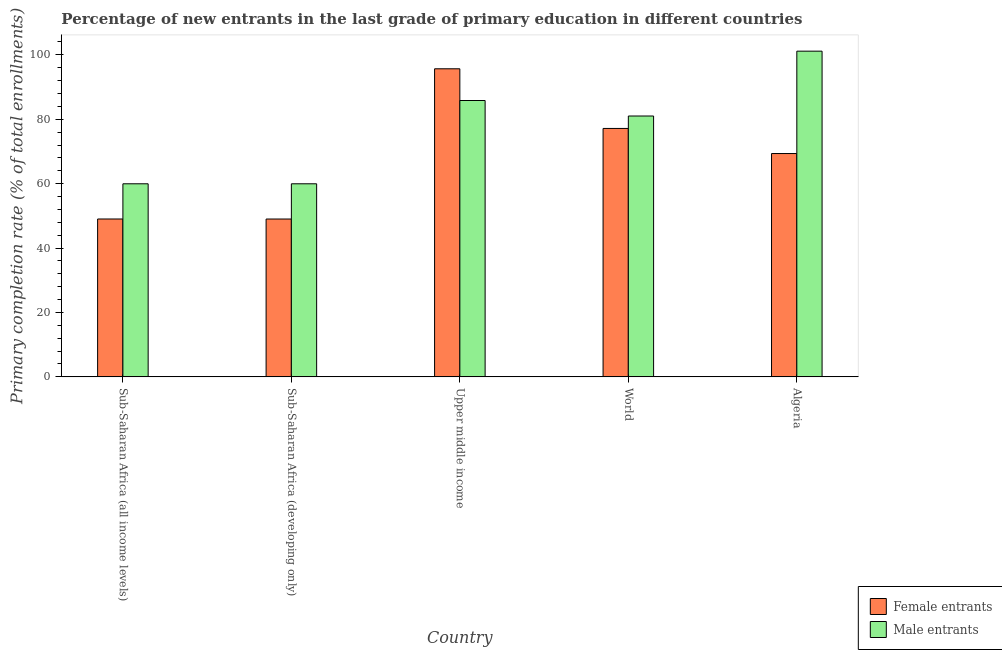How many groups of bars are there?
Your answer should be compact. 5. Are the number of bars per tick equal to the number of legend labels?
Ensure brevity in your answer.  Yes. Are the number of bars on each tick of the X-axis equal?
Provide a short and direct response. Yes. How many bars are there on the 3rd tick from the left?
Offer a terse response. 2. How many bars are there on the 3rd tick from the right?
Your response must be concise. 2. What is the label of the 2nd group of bars from the left?
Provide a short and direct response. Sub-Saharan Africa (developing only). What is the primary completion rate of male entrants in World?
Give a very brief answer. 81.01. Across all countries, what is the maximum primary completion rate of male entrants?
Offer a very short reply. 101.14. Across all countries, what is the minimum primary completion rate of male entrants?
Provide a succinct answer. 59.96. In which country was the primary completion rate of female entrants maximum?
Ensure brevity in your answer.  Upper middle income. In which country was the primary completion rate of male entrants minimum?
Offer a terse response. Sub-Saharan Africa (developing only). What is the total primary completion rate of male entrants in the graph?
Offer a very short reply. 387.89. What is the difference between the primary completion rate of male entrants in Algeria and that in Sub-Saharan Africa (developing only)?
Make the answer very short. 41.19. What is the difference between the primary completion rate of male entrants in Sub-Saharan Africa (all income levels) and the primary completion rate of female entrants in Sub-Saharan Africa (developing only)?
Your answer should be very brief. 10.94. What is the average primary completion rate of female entrants per country?
Offer a terse response. 68.04. What is the difference between the primary completion rate of male entrants and primary completion rate of female entrants in Sub-Saharan Africa (all income levels)?
Your answer should be compact. 10.94. In how many countries, is the primary completion rate of female entrants greater than 64 %?
Offer a very short reply. 3. What is the ratio of the primary completion rate of female entrants in Sub-Saharan Africa (developing only) to that in Upper middle income?
Your response must be concise. 0.51. What is the difference between the highest and the second highest primary completion rate of female entrants?
Provide a succinct answer. 18.52. What is the difference between the highest and the lowest primary completion rate of male entrants?
Your answer should be very brief. 41.19. Is the sum of the primary completion rate of male entrants in Algeria and World greater than the maximum primary completion rate of female entrants across all countries?
Offer a very short reply. Yes. What does the 1st bar from the left in Upper middle income represents?
Keep it short and to the point. Female entrants. What does the 1st bar from the right in Upper middle income represents?
Ensure brevity in your answer.  Male entrants. Are all the bars in the graph horizontal?
Ensure brevity in your answer.  No. What is the difference between two consecutive major ticks on the Y-axis?
Keep it short and to the point. 20. Does the graph contain any zero values?
Keep it short and to the point. No. Where does the legend appear in the graph?
Provide a succinct answer. Bottom right. How many legend labels are there?
Give a very brief answer. 2. What is the title of the graph?
Give a very brief answer. Percentage of new entrants in the last grade of primary education in different countries. What is the label or title of the Y-axis?
Give a very brief answer. Primary completion rate (% of total enrollments). What is the Primary completion rate (% of total enrollments) of Female entrants in Sub-Saharan Africa (all income levels)?
Give a very brief answer. 49.02. What is the Primary completion rate (% of total enrollments) in Male entrants in Sub-Saharan Africa (all income levels)?
Offer a very short reply. 59.96. What is the Primary completion rate (% of total enrollments) of Female entrants in Sub-Saharan Africa (developing only)?
Your answer should be very brief. 49.02. What is the Primary completion rate (% of total enrollments) of Male entrants in Sub-Saharan Africa (developing only)?
Your response must be concise. 59.96. What is the Primary completion rate (% of total enrollments) in Female entrants in Upper middle income?
Make the answer very short. 95.67. What is the Primary completion rate (% of total enrollments) of Male entrants in Upper middle income?
Provide a succinct answer. 85.82. What is the Primary completion rate (% of total enrollments) in Female entrants in World?
Provide a short and direct response. 77.14. What is the Primary completion rate (% of total enrollments) in Male entrants in World?
Give a very brief answer. 81.01. What is the Primary completion rate (% of total enrollments) in Female entrants in Algeria?
Your answer should be compact. 69.35. What is the Primary completion rate (% of total enrollments) in Male entrants in Algeria?
Give a very brief answer. 101.14. Across all countries, what is the maximum Primary completion rate (% of total enrollments) of Female entrants?
Provide a succinct answer. 95.67. Across all countries, what is the maximum Primary completion rate (% of total enrollments) in Male entrants?
Offer a terse response. 101.14. Across all countries, what is the minimum Primary completion rate (% of total enrollments) in Female entrants?
Your response must be concise. 49.02. Across all countries, what is the minimum Primary completion rate (% of total enrollments) in Male entrants?
Keep it short and to the point. 59.96. What is the total Primary completion rate (% of total enrollments) of Female entrants in the graph?
Provide a short and direct response. 340.21. What is the total Primary completion rate (% of total enrollments) in Male entrants in the graph?
Ensure brevity in your answer.  387.89. What is the difference between the Primary completion rate (% of total enrollments) of Female entrants in Sub-Saharan Africa (all income levels) and that in Sub-Saharan Africa (developing only)?
Make the answer very short. 0.01. What is the difference between the Primary completion rate (% of total enrollments) in Male entrants in Sub-Saharan Africa (all income levels) and that in Sub-Saharan Africa (developing only)?
Offer a very short reply. 0. What is the difference between the Primary completion rate (% of total enrollments) of Female entrants in Sub-Saharan Africa (all income levels) and that in Upper middle income?
Give a very brief answer. -46.64. What is the difference between the Primary completion rate (% of total enrollments) in Male entrants in Sub-Saharan Africa (all income levels) and that in Upper middle income?
Give a very brief answer. -25.86. What is the difference between the Primary completion rate (% of total enrollments) in Female entrants in Sub-Saharan Africa (all income levels) and that in World?
Offer a terse response. -28.12. What is the difference between the Primary completion rate (% of total enrollments) of Male entrants in Sub-Saharan Africa (all income levels) and that in World?
Make the answer very short. -21.05. What is the difference between the Primary completion rate (% of total enrollments) of Female entrants in Sub-Saharan Africa (all income levels) and that in Algeria?
Offer a terse response. -20.33. What is the difference between the Primary completion rate (% of total enrollments) in Male entrants in Sub-Saharan Africa (all income levels) and that in Algeria?
Keep it short and to the point. -41.18. What is the difference between the Primary completion rate (% of total enrollments) in Female entrants in Sub-Saharan Africa (developing only) and that in Upper middle income?
Provide a succinct answer. -46.65. What is the difference between the Primary completion rate (% of total enrollments) of Male entrants in Sub-Saharan Africa (developing only) and that in Upper middle income?
Your answer should be very brief. -25.86. What is the difference between the Primary completion rate (% of total enrollments) of Female entrants in Sub-Saharan Africa (developing only) and that in World?
Offer a very short reply. -28.13. What is the difference between the Primary completion rate (% of total enrollments) in Male entrants in Sub-Saharan Africa (developing only) and that in World?
Your response must be concise. -21.05. What is the difference between the Primary completion rate (% of total enrollments) in Female entrants in Sub-Saharan Africa (developing only) and that in Algeria?
Your response must be concise. -20.34. What is the difference between the Primary completion rate (% of total enrollments) in Male entrants in Sub-Saharan Africa (developing only) and that in Algeria?
Provide a succinct answer. -41.19. What is the difference between the Primary completion rate (% of total enrollments) in Female entrants in Upper middle income and that in World?
Your answer should be compact. 18.52. What is the difference between the Primary completion rate (% of total enrollments) of Male entrants in Upper middle income and that in World?
Keep it short and to the point. 4.81. What is the difference between the Primary completion rate (% of total enrollments) of Female entrants in Upper middle income and that in Algeria?
Offer a terse response. 26.32. What is the difference between the Primary completion rate (% of total enrollments) of Male entrants in Upper middle income and that in Algeria?
Your response must be concise. -15.32. What is the difference between the Primary completion rate (% of total enrollments) of Female entrants in World and that in Algeria?
Offer a terse response. 7.79. What is the difference between the Primary completion rate (% of total enrollments) of Male entrants in World and that in Algeria?
Provide a short and direct response. -20.14. What is the difference between the Primary completion rate (% of total enrollments) in Female entrants in Sub-Saharan Africa (all income levels) and the Primary completion rate (% of total enrollments) in Male entrants in Sub-Saharan Africa (developing only)?
Your answer should be very brief. -10.93. What is the difference between the Primary completion rate (% of total enrollments) in Female entrants in Sub-Saharan Africa (all income levels) and the Primary completion rate (% of total enrollments) in Male entrants in Upper middle income?
Provide a short and direct response. -36.8. What is the difference between the Primary completion rate (% of total enrollments) in Female entrants in Sub-Saharan Africa (all income levels) and the Primary completion rate (% of total enrollments) in Male entrants in World?
Your response must be concise. -31.98. What is the difference between the Primary completion rate (% of total enrollments) of Female entrants in Sub-Saharan Africa (all income levels) and the Primary completion rate (% of total enrollments) of Male entrants in Algeria?
Provide a succinct answer. -52.12. What is the difference between the Primary completion rate (% of total enrollments) of Female entrants in Sub-Saharan Africa (developing only) and the Primary completion rate (% of total enrollments) of Male entrants in Upper middle income?
Your answer should be very brief. -36.8. What is the difference between the Primary completion rate (% of total enrollments) of Female entrants in Sub-Saharan Africa (developing only) and the Primary completion rate (% of total enrollments) of Male entrants in World?
Provide a short and direct response. -31.99. What is the difference between the Primary completion rate (% of total enrollments) of Female entrants in Sub-Saharan Africa (developing only) and the Primary completion rate (% of total enrollments) of Male entrants in Algeria?
Provide a short and direct response. -52.13. What is the difference between the Primary completion rate (% of total enrollments) of Female entrants in Upper middle income and the Primary completion rate (% of total enrollments) of Male entrants in World?
Your answer should be very brief. 14.66. What is the difference between the Primary completion rate (% of total enrollments) of Female entrants in Upper middle income and the Primary completion rate (% of total enrollments) of Male entrants in Algeria?
Your response must be concise. -5.48. What is the difference between the Primary completion rate (% of total enrollments) of Female entrants in World and the Primary completion rate (% of total enrollments) of Male entrants in Algeria?
Your answer should be compact. -24. What is the average Primary completion rate (% of total enrollments) of Female entrants per country?
Ensure brevity in your answer.  68.04. What is the average Primary completion rate (% of total enrollments) in Male entrants per country?
Provide a succinct answer. 77.58. What is the difference between the Primary completion rate (% of total enrollments) of Female entrants and Primary completion rate (% of total enrollments) of Male entrants in Sub-Saharan Africa (all income levels)?
Offer a very short reply. -10.94. What is the difference between the Primary completion rate (% of total enrollments) in Female entrants and Primary completion rate (% of total enrollments) in Male entrants in Sub-Saharan Africa (developing only)?
Your answer should be very brief. -10.94. What is the difference between the Primary completion rate (% of total enrollments) in Female entrants and Primary completion rate (% of total enrollments) in Male entrants in Upper middle income?
Make the answer very short. 9.85. What is the difference between the Primary completion rate (% of total enrollments) in Female entrants and Primary completion rate (% of total enrollments) in Male entrants in World?
Offer a terse response. -3.86. What is the difference between the Primary completion rate (% of total enrollments) in Female entrants and Primary completion rate (% of total enrollments) in Male entrants in Algeria?
Keep it short and to the point. -31.79. What is the ratio of the Primary completion rate (% of total enrollments) in Male entrants in Sub-Saharan Africa (all income levels) to that in Sub-Saharan Africa (developing only)?
Your answer should be compact. 1. What is the ratio of the Primary completion rate (% of total enrollments) in Female entrants in Sub-Saharan Africa (all income levels) to that in Upper middle income?
Make the answer very short. 0.51. What is the ratio of the Primary completion rate (% of total enrollments) in Male entrants in Sub-Saharan Africa (all income levels) to that in Upper middle income?
Give a very brief answer. 0.7. What is the ratio of the Primary completion rate (% of total enrollments) of Female entrants in Sub-Saharan Africa (all income levels) to that in World?
Offer a terse response. 0.64. What is the ratio of the Primary completion rate (% of total enrollments) of Male entrants in Sub-Saharan Africa (all income levels) to that in World?
Ensure brevity in your answer.  0.74. What is the ratio of the Primary completion rate (% of total enrollments) in Female entrants in Sub-Saharan Africa (all income levels) to that in Algeria?
Your response must be concise. 0.71. What is the ratio of the Primary completion rate (% of total enrollments) in Male entrants in Sub-Saharan Africa (all income levels) to that in Algeria?
Make the answer very short. 0.59. What is the ratio of the Primary completion rate (% of total enrollments) of Female entrants in Sub-Saharan Africa (developing only) to that in Upper middle income?
Your response must be concise. 0.51. What is the ratio of the Primary completion rate (% of total enrollments) of Male entrants in Sub-Saharan Africa (developing only) to that in Upper middle income?
Ensure brevity in your answer.  0.7. What is the ratio of the Primary completion rate (% of total enrollments) in Female entrants in Sub-Saharan Africa (developing only) to that in World?
Provide a short and direct response. 0.64. What is the ratio of the Primary completion rate (% of total enrollments) in Male entrants in Sub-Saharan Africa (developing only) to that in World?
Keep it short and to the point. 0.74. What is the ratio of the Primary completion rate (% of total enrollments) in Female entrants in Sub-Saharan Africa (developing only) to that in Algeria?
Offer a very short reply. 0.71. What is the ratio of the Primary completion rate (% of total enrollments) in Male entrants in Sub-Saharan Africa (developing only) to that in Algeria?
Offer a terse response. 0.59. What is the ratio of the Primary completion rate (% of total enrollments) in Female entrants in Upper middle income to that in World?
Make the answer very short. 1.24. What is the ratio of the Primary completion rate (% of total enrollments) in Male entrants in Upper middle income to that in World?
Offer a terse response. 1.06. What is the ratio of the Primary completion rate (% of total enrollments) in Female entrants in Upper middle income to that in Algeria?
Provide a short and direct response. 1.38. What is the ratio of the Primary completion rate (% of total enrollments) in Male entrants in Upper middle income to that in Algeria?
Ensure brevity in your answer.  0.85. What is the ratio of the Primary completion rate (% of total enrollments) of Female entrants in World to that in Algeria?
Ensure brevity in your answer.  1.11. What is the ratio of the Primary completion rate (% of total enrollments) of Male entrants in World to that in Algeria?
Offer a terse response. 0.8. What is the difference between the highest and the second highest Primary completion rate (% of total enrollments) in Female entrants?
Your response must be concise. 18.52. What is the difference between the highest and the second highest Primary completion rate (% of total enrollments) of Male entrants?
Provide a short and direct response. 15.32. What is the difference between the highest and the lowest Primary completion rate (% of total enrollments) in Female entrants?
Your answer should be compact. 46.65. What is the difference between the highest and the lowest Primary completion rate (% of total enrollments) in Male entrants?
Make the answer very short. 41.19. 